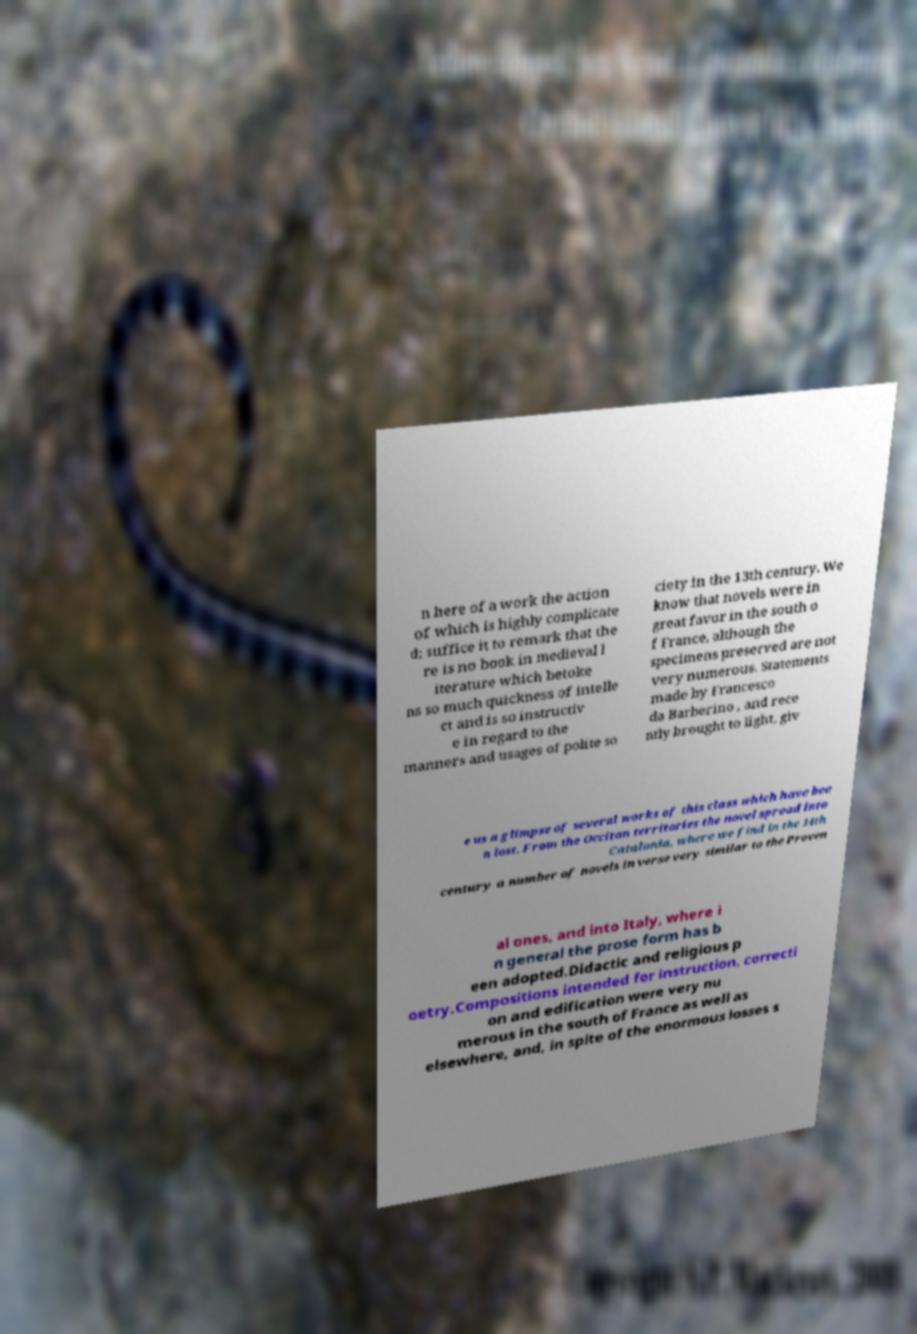Please read and relay the text visible in this image. What does it say? n here of a work the action of which is highly complicate d; suffice it to remark that the re is no book in medieval l iterature which betoke ns so much quickness of intelle ct and is so instructiv e in regard to the manners and usages of polite so ciety in the 13th century. We know that novels were in great favor in the south o f France, although the specimens preserved are not very numerous. Statements made by Francesco da Barberino , and rece ntly brought to light, giv e us a glimpse of several works of this class which have bee n lost. From the Occitan territories the novel spread into Catalonia, where we find in the 14th century a number of novels in verse very similar to the Proven al ones, and into Italy, where i n general the prose form has b een adopted.Didactic and religious p oetry.Compositions intended for instruction, correcti on and edification were very nu merous in the south of France as well as elsewhere, and, in spite of the enormous losses s 